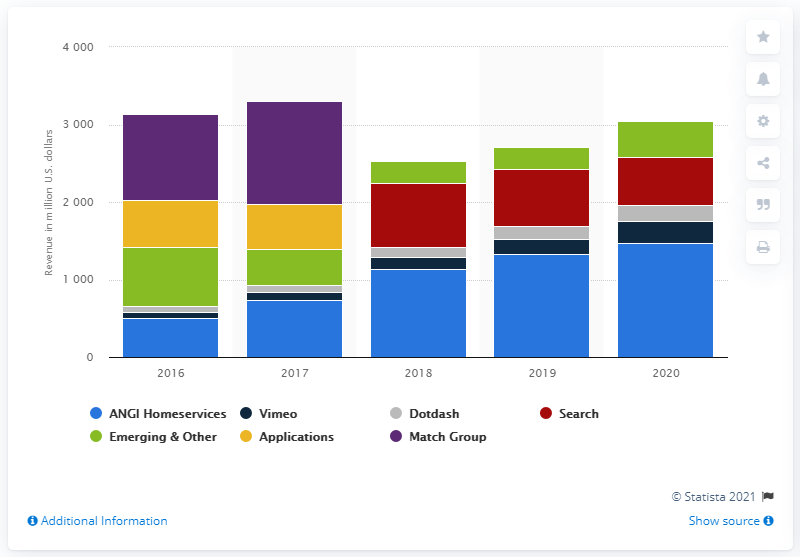Point out several critical features in this image. In 2020, the revenue generated by IAC's Vimeo segment was $283.2 million. IAC's previous revenue in the Vimeo segment was approximately $196 million. 